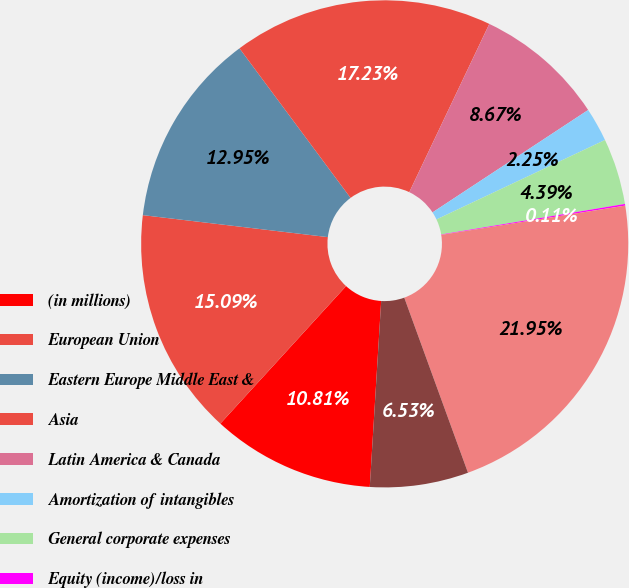Convert chart. <chart><loc_0><loc_0><loc_500><loc_500><pie_chart><fcel>(in millions)<fcel>European Union<fcel>Eastern Europe Middle East &<fcel>Asia<fcel>Latin America & Canada<fcel>Amortization of intangibles<fcel>General corporate expenses<fcel>Equity (income)/loss in<fcel>Operating income<fcel>Interest expense net<nl><fcel>10.81%<fcel>15.09%<fcel>12.95%<fcel>17.23%<fcel>8.67%<fcel>2.25%<fcel>4.39%<fcel>0.11%<fcel>21.95%<fcel>6.53%<nl></chart> 